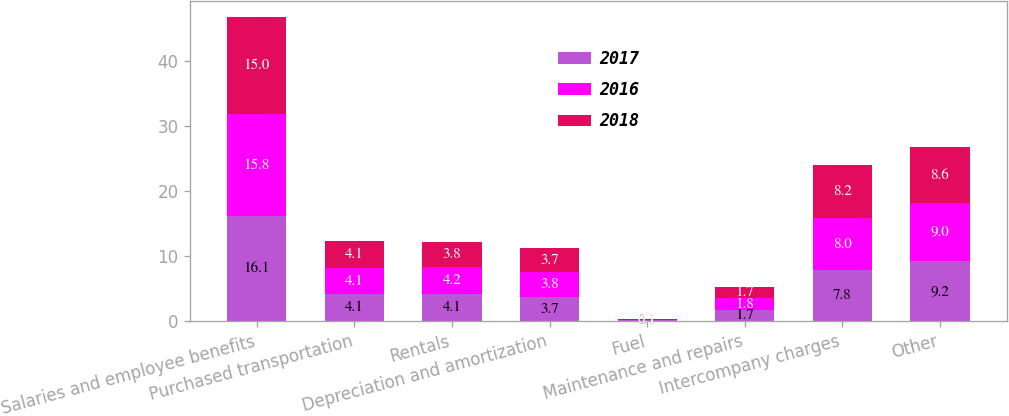<chart> <loc_0><loc_0><loc_500><loc_500><stacked_bar_chart><ecel><fcel>Salaries and employee benefits<fcel>Purchased transportation<fcel>Rentals<fcel>Depreciation and amortization<fcel>Fuel<fcel>Maintenance and repairs<fcel>Intercompany charges<fcel>Other<nl><fcel>2017<fcel>16.1<fcel>4.1<fcel>4.1<fcel>3.7<fcel>0.1<fcel>1.7<fcel>7.8<fcel>9.2<nl><fcel>2016<fcel>15.8<fcel>4.1<fcel>4.2<fcel>3.8<fcel>0.1<fcel>1.8<fcel>8<fcel>9<nl><fcel>2018<fcel>15<fcel>4.1<fcel>3.8<fcel>3.7<fcel>0.1<fcel>1.7<fcel>8.2<fcel>8.6<nl></chart> 